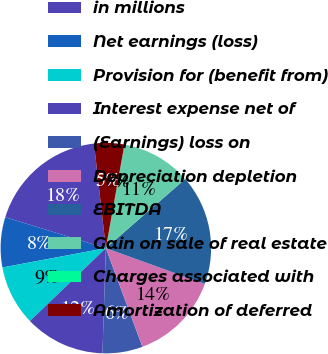<chart> <loc_0><loc_0><loc_500><loc_500><pie_chart><fcel>in millions<fcel>Net earnings (loss)<fcel>Provision for (benefit from)<fcel>Interest expense net of<fcel>(Earnings) loss on<fcel>Depreciation depletion<fcel>EBITDA<fcel>Gain on sale of real estate<fcel>Charges associated with<fcel>Amortization of deferred<nl><fcel>18.46%<fcel>7.69%<fcel>9.23%<fcel>12.31%<fcel>6.16%<fcel>13.84%<fcel>16.92%<fcel>10.77%<fcel>0.0%<fcel>4.62%<nl></chart> 